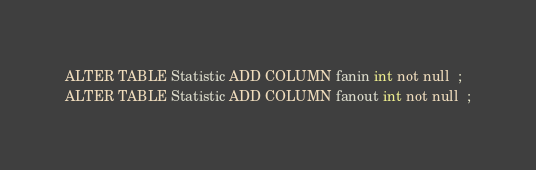<code> <loc_0><loc_0><loc_500><loc_500><_SQL_>ALTER TABLE Statistic ADD COLUMN fanin int not null  ;
ALTER TABLE Statistic ADD COLUMN fanout int not null  ;


</code> 